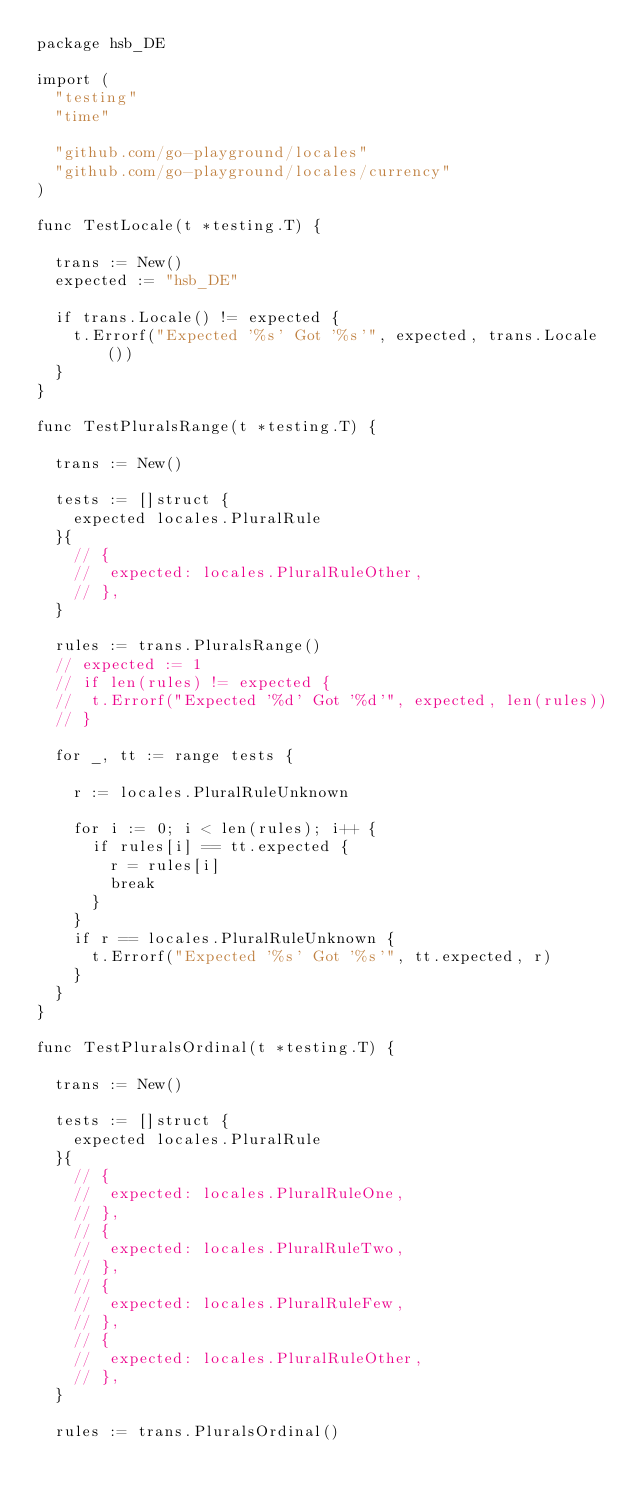Convert code to text. <code><loc_0><loc_0><loc_500><loc_500><_Go_>package hsb_DE

import (
	"testing"
	"time"

	"github.com/go-playground/locales"
	"github.com/go-playground/locales/currency"
)

func TestLocale(t *testing.T) {

	trans := New()
	expected := "hsb_DE"

	if trans.Locale() != expected {
		t.Errorf("Expected '%s' Got '%s'", expected, trans.Locale())
	}
}

func TestPluralsRange(t *testing.T) {

	trans := New()

	tests := []struct {
		expected locales.PluralRule
	}{
		// {
		// 	expected: locales.PluralRuleOther,
		// },
	}

	rules := trans.PluralsRange()
	// expected := 1
	// if len(rules) != expected {
	// 	t.Errorf("Expected '%d' Got '%d'", expected, len(rules))
	// }

	for _, tt := range tests {

		r := locales.PluralRuleUnknown

		for i := 0; i < len(rules); i++ {
			if rules[i] == tt.expected {
				r = rules[i]
				break
			}
		}
		if r == locales.PluralRuleUnknown {
			t.Errorf("Expected '%s' Got '%s'", tt.expected, r)
		}
	}
}

func TestPluralsOrdinal(t *testing.T) {

	trans := New()

	tests := []struct {
		expected locales.PluralRule
	}{
		// {
		// 	expected: locales.PluralRuleOne,
		// },
		// {
		// 	expected: locales.PluralRuleTwo,
		// },
		// {
		// 	expected: locales.PluralRuleFew,
		// },
		// {
		// 	expected: locales.PluralRuleOther,
		// },
	}

	rules := trans.PluralsOrdinal()</code> 